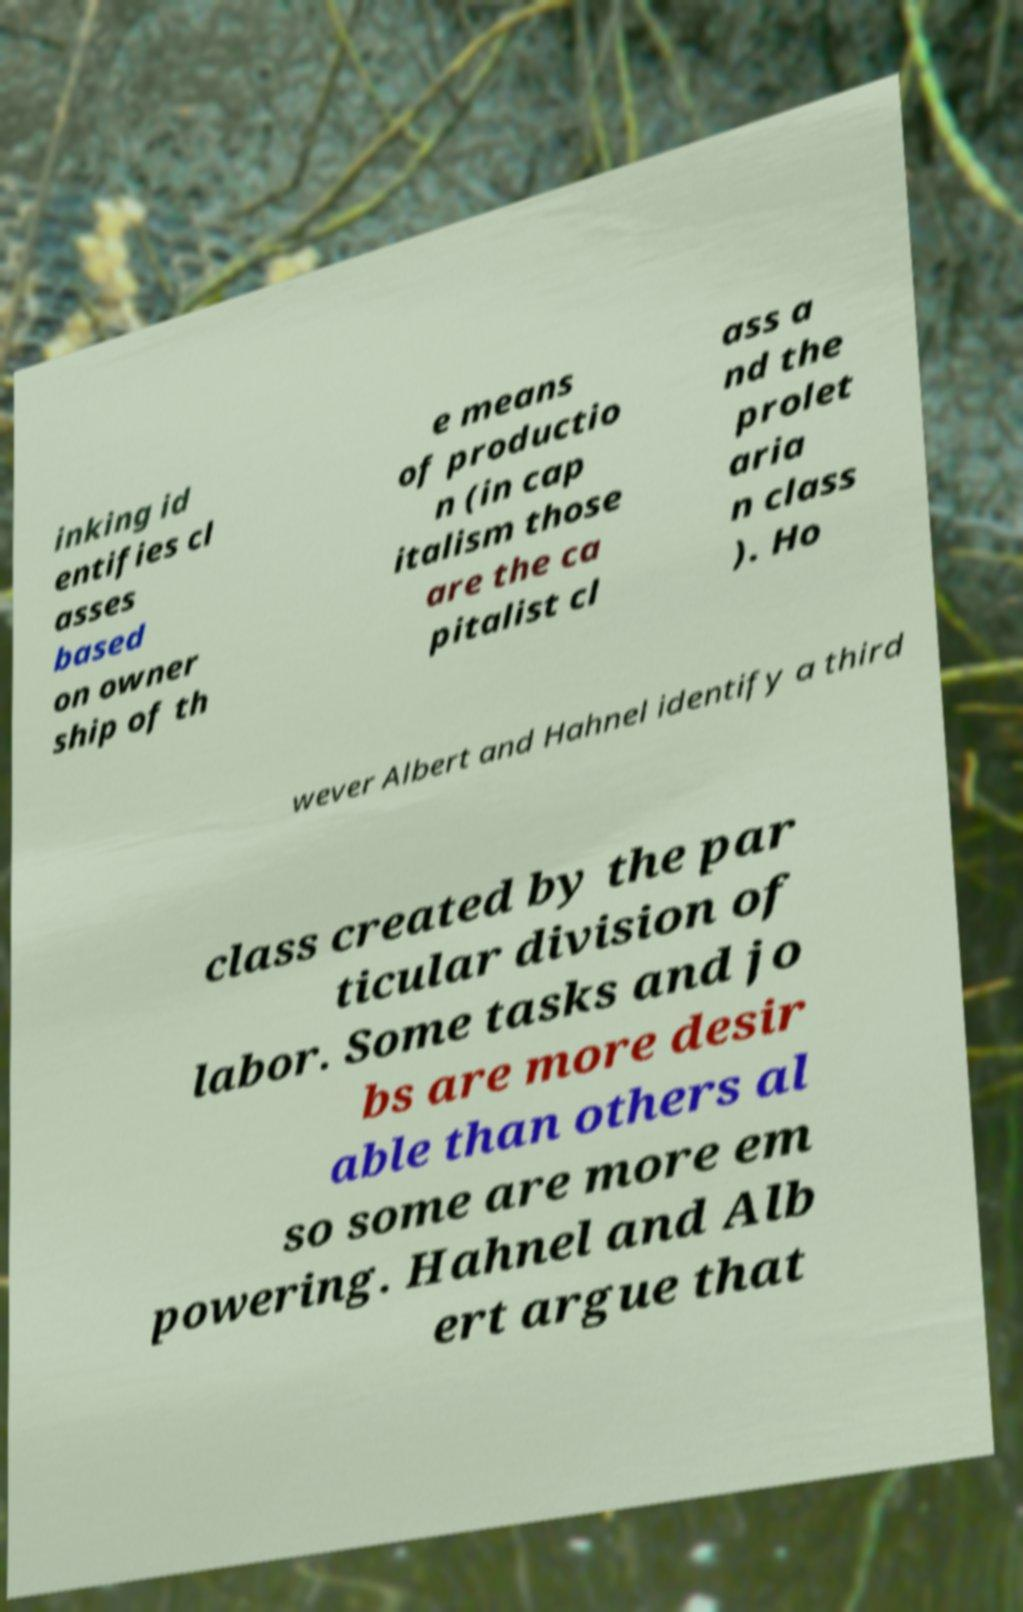For documentation purposes, I need the text within this image transcribed. Could you provide that? inking id entifies cl asses based on owner ship of th e means of productio n (in cap italism those are the ca pitalist cl ass a nd the prolet aria n class ). Ho wever Albert and Hahnel identify a third class created by the par ticular division of labor. Some tasks and jo bs are more desir able than others al so some are more em powering. Hahnel and Alb ert argue that 